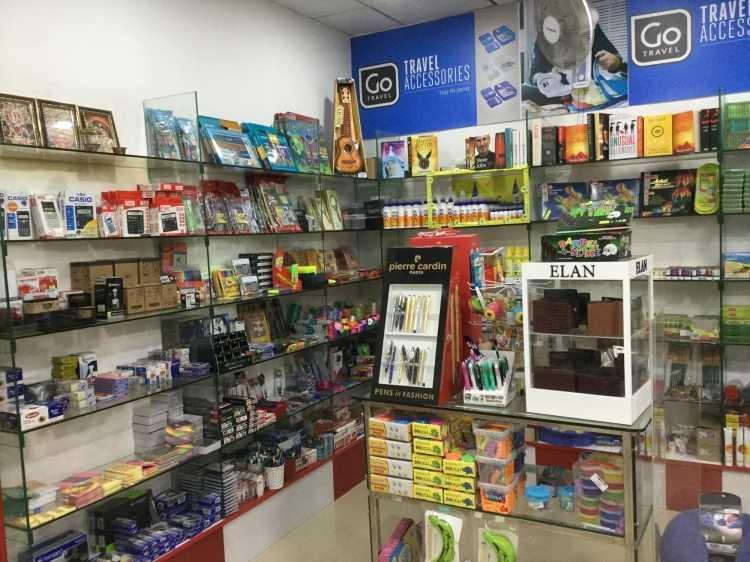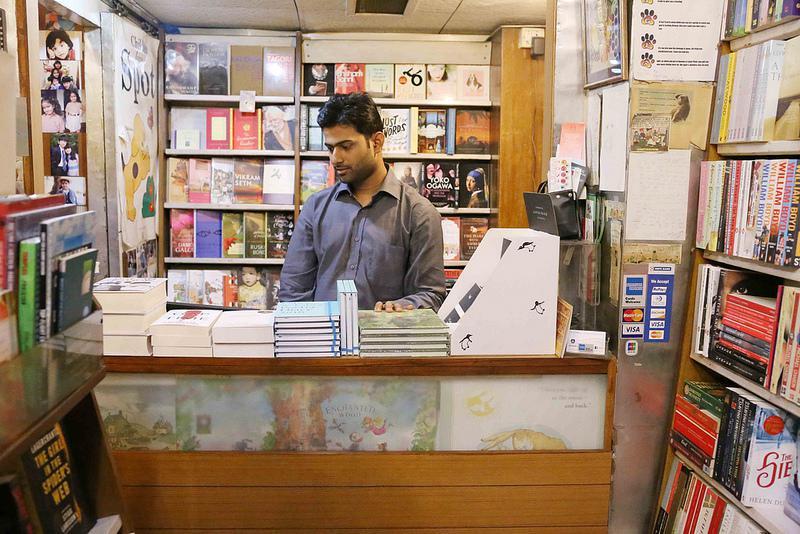The first image is the image on the left, the second image is the image on the right. Assess this claim about the two images: "In at  least one image there is a single man with black hair and brown skin in a button up shirt surrounded by at least 100 books.". Correct or not? Answer yes or no. Yes. 